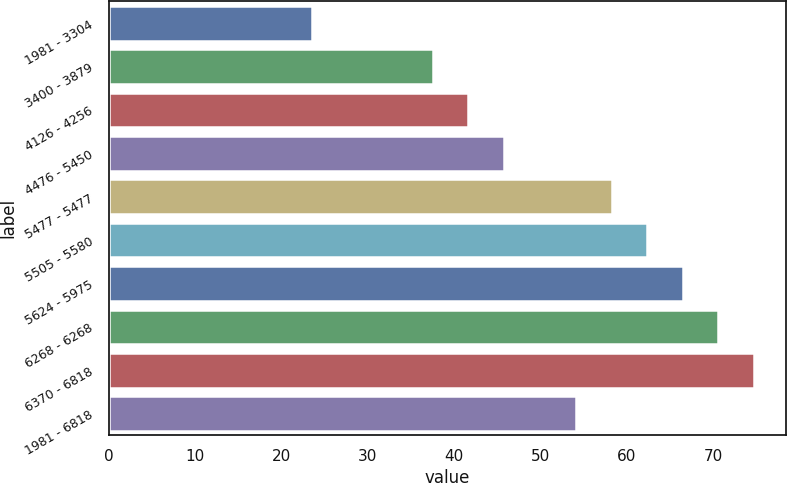Convert chart. <chart><loc_0><loc_0><loc_500><loc_500><bar_chart><fcel>1981 - 3304<fcel>3400 - 3879<fcel>4126 - 4256<fcel>4476 - 5450<fcel>5477 - 5477<fcel>5505 - 5580<fcel>5624 - 5975<fcel>6268 - 6268<fcel>6370 - 6818<fcel>1981 - 6818<nl><fcel>23.52<fcel>37.52<fcel>41.63<fcel>45.74<fcel>58.26<fcel>62.37<fcel>66.48<fcel>70.59<fcel>74.7<fcel>54.15<nl></chart> 